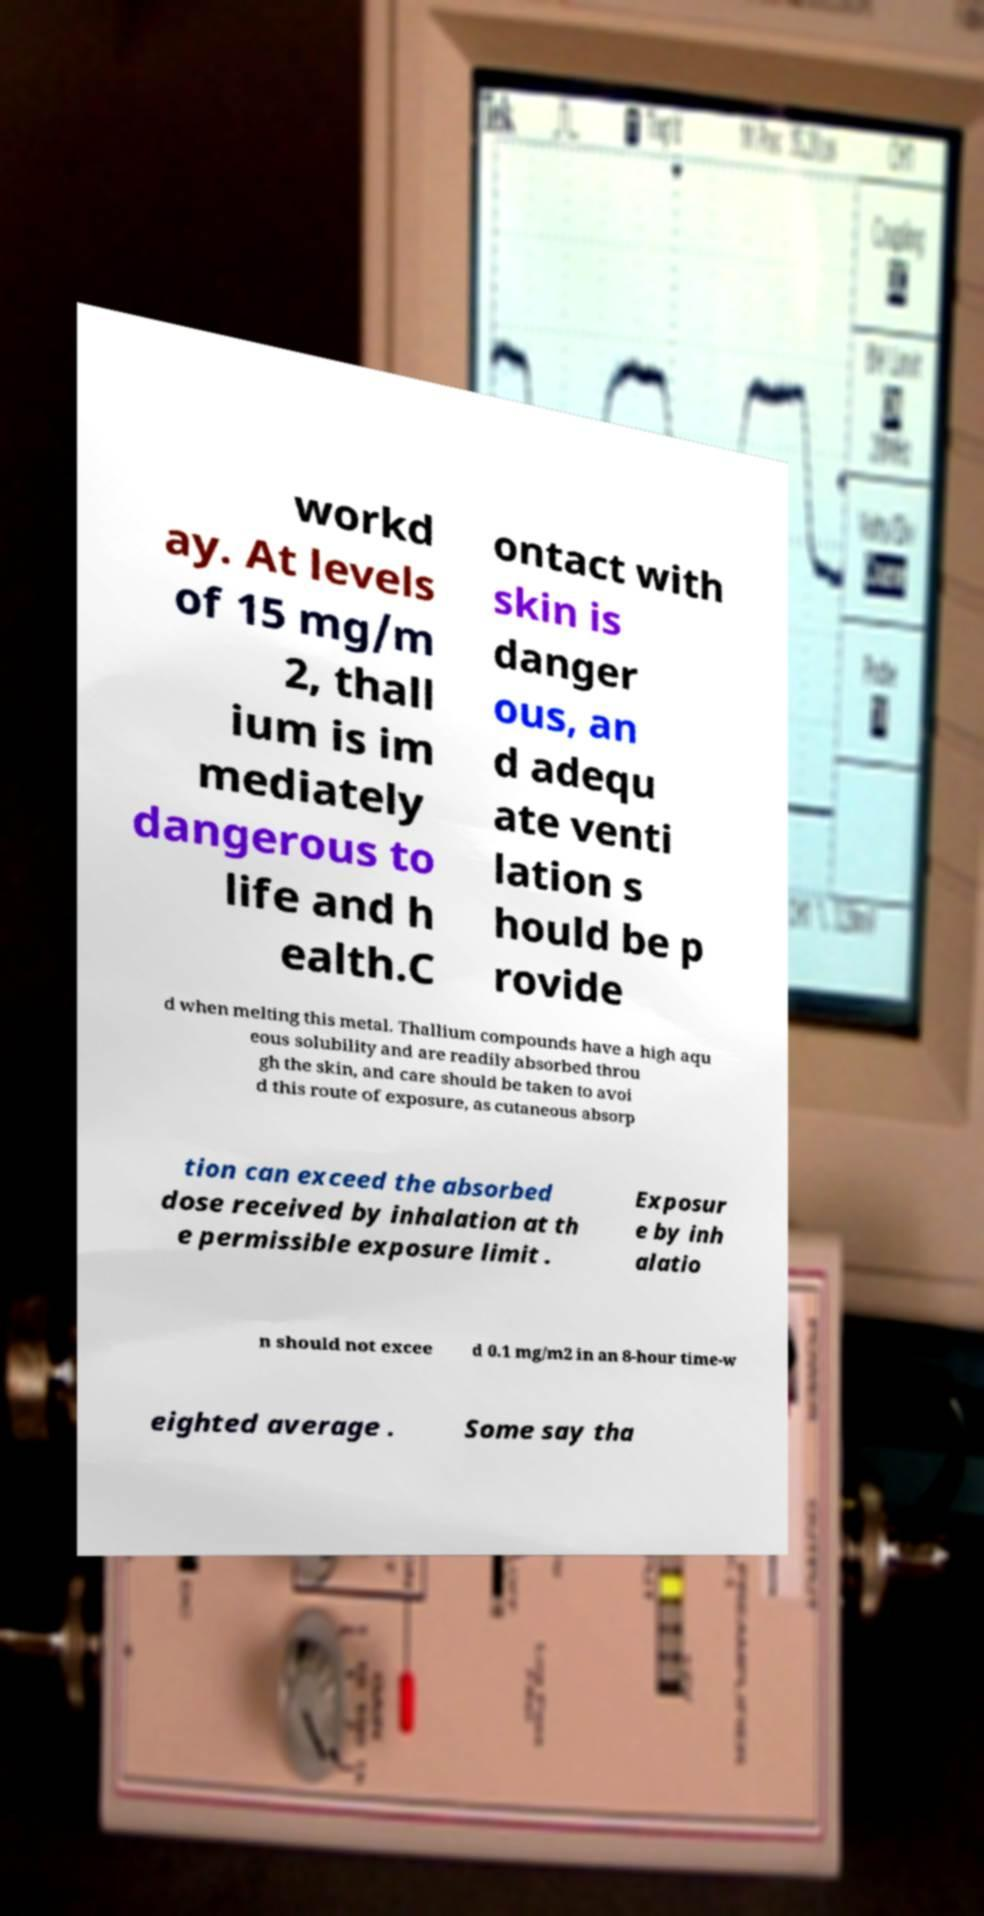Could you extract and type out the text from this image? workd ay. At levels of 15 mg/m 2, thall ium is im mediately dangerous to life and h ealth.C ontact with skin is danger ous, an d adequ ate venti lation s hould be p rovide d when melting this metal. Thallium compounds have a high aqu eous solubility and are readily absorbed throu gh the skin, and care should be taken to avoi d this route of exposure, as cutaneous absorp tion can exceed the absorbed dose received by inhalation at th e permissible exposure limit . Exposur e by inh alatio n should not excee d 0.1 mg/m2 in an 8-hour time-w eighted average . Some say tha 